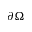<formula> <loc_0><loc_0><loc_500><loc_500>\partial \Omega</formula> 